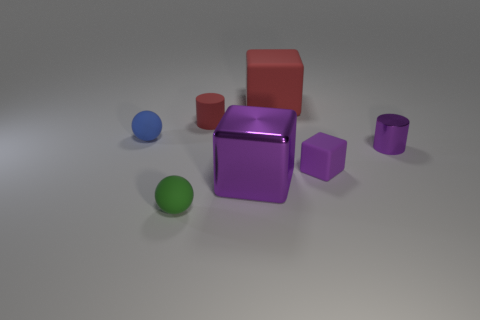What shape is the big metal object that is the same color as the small metallic thing?
Give a very brief answer. Cube. What number of tiny purple metallic things have the same shape as the big red matte thing?
Offer a very short reply. 0. What number of rubber things are to the left of the red block and in front of the tiny red cylinder?
Your answer should be very brief. 2. What color is the large matte thing?
Keep it short and to the point. Red. Is there a tiny cube made of the same material as the big red object?
Ensure brevity in your answer.  Yes. Are there any red rubber cylinders that are to the right of the tiny rubber thing that is behind the small sphere that is behind the small green object?
Your answer should be very brief. No. Are there any tiny matte objects left of the purple metallic cylinder?
Give a very brief answer. Yes. Are there any matte objects that have the same color as the tiny metal thing?
Make the answer very short. Yes. What number of small objects are either brown metal cylinders or red matte blocks?
Your answer should be compact. 0. Does the sphere that is to the right of the blue sphere have the same material as the big purple object?
Offer a terse response. No. 